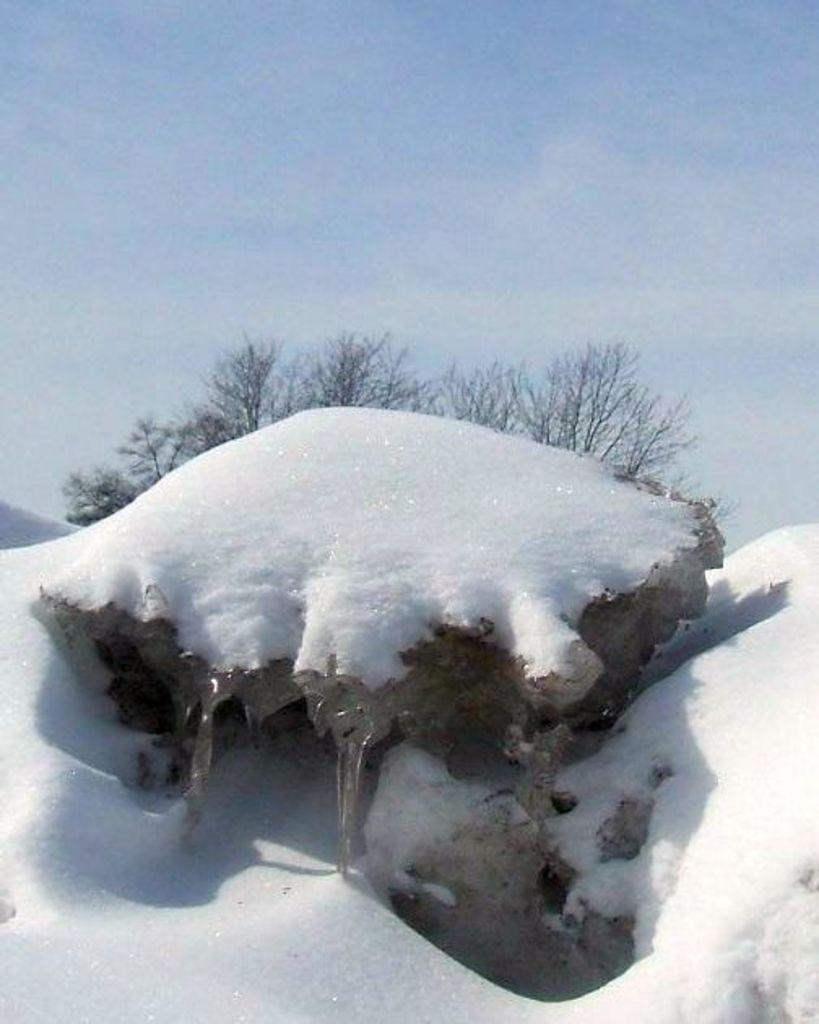In one or two sentences, can you explain what this image depicts? In this image I can see the rock covered with snow. In the background I can see the trees and the sky. 